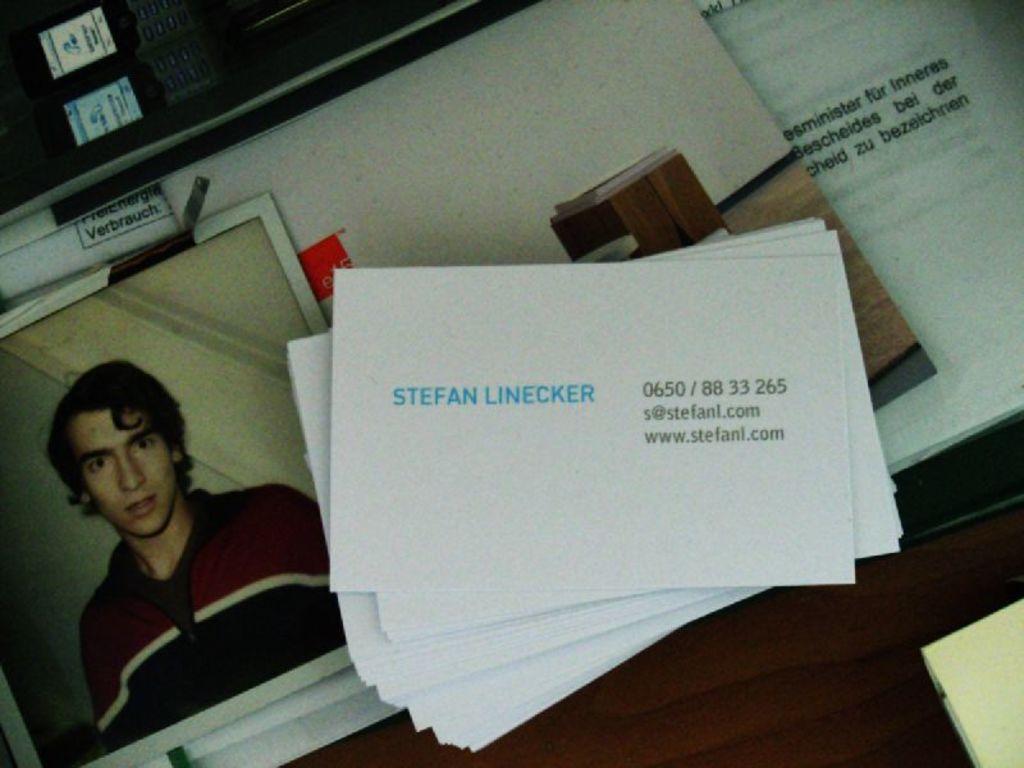What name is on the business card?
Your response must be concise. Stefan linecker. What's the contact number on the business card?
Keep it short and to the point. 0650/88 33 265. 